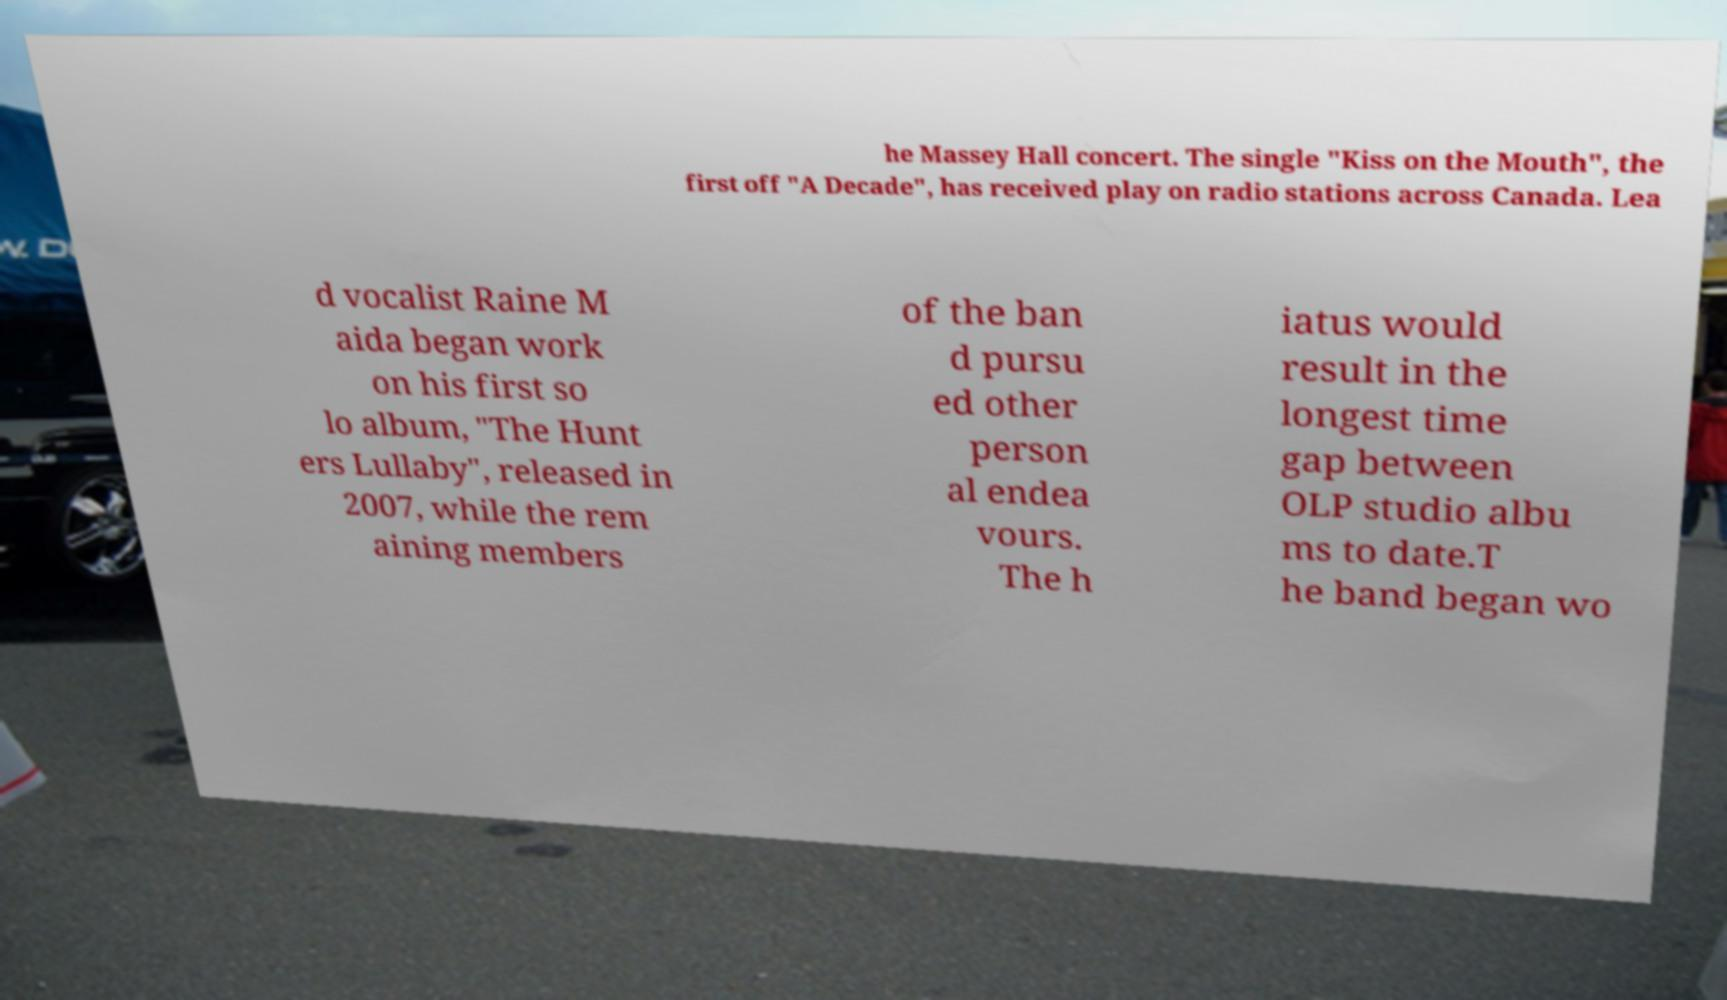What messages or text are displayed in this image? I need them in a readable, typed format. he Massey Hall concert. The single "Kiss on the Mouth", the first off "A Decade", has received play on radio stations across Canada. Lea d vocalist Raine M aida began work on his first so lo album, "The Hunt ers Lullaby", released in 2007, while the rem aining members of the ban d pursu ed other person al endea vours. The h iatus would result in the longest time gap between OLP studio albu ms to date.T he band began wo 